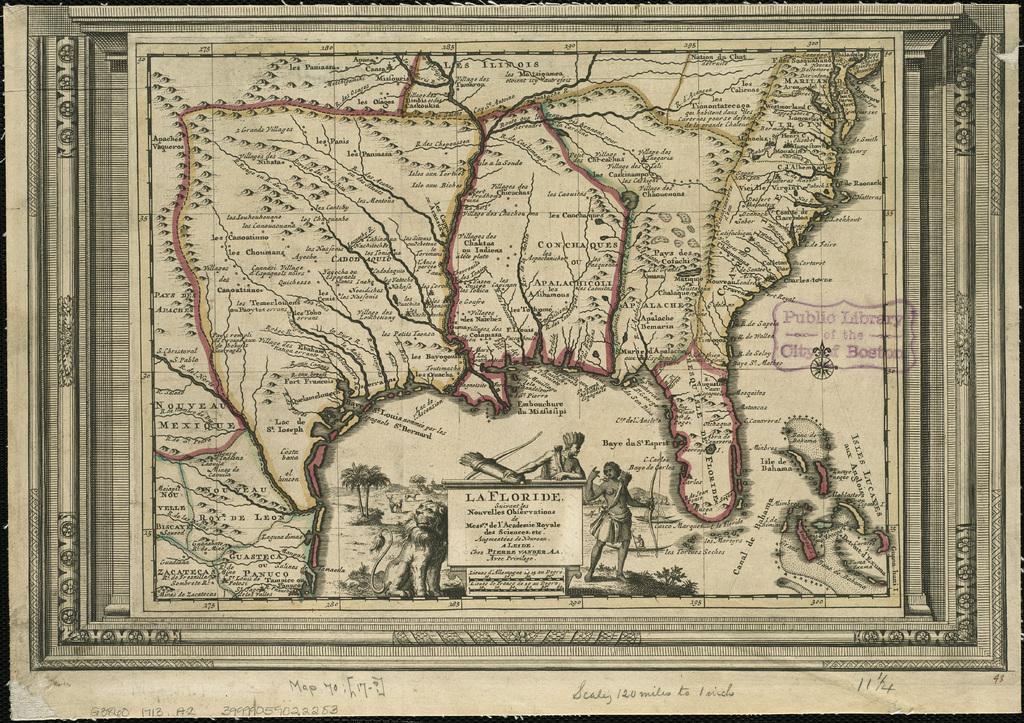Can you describe this image briefly? In the image there is an ancient map of a city. 